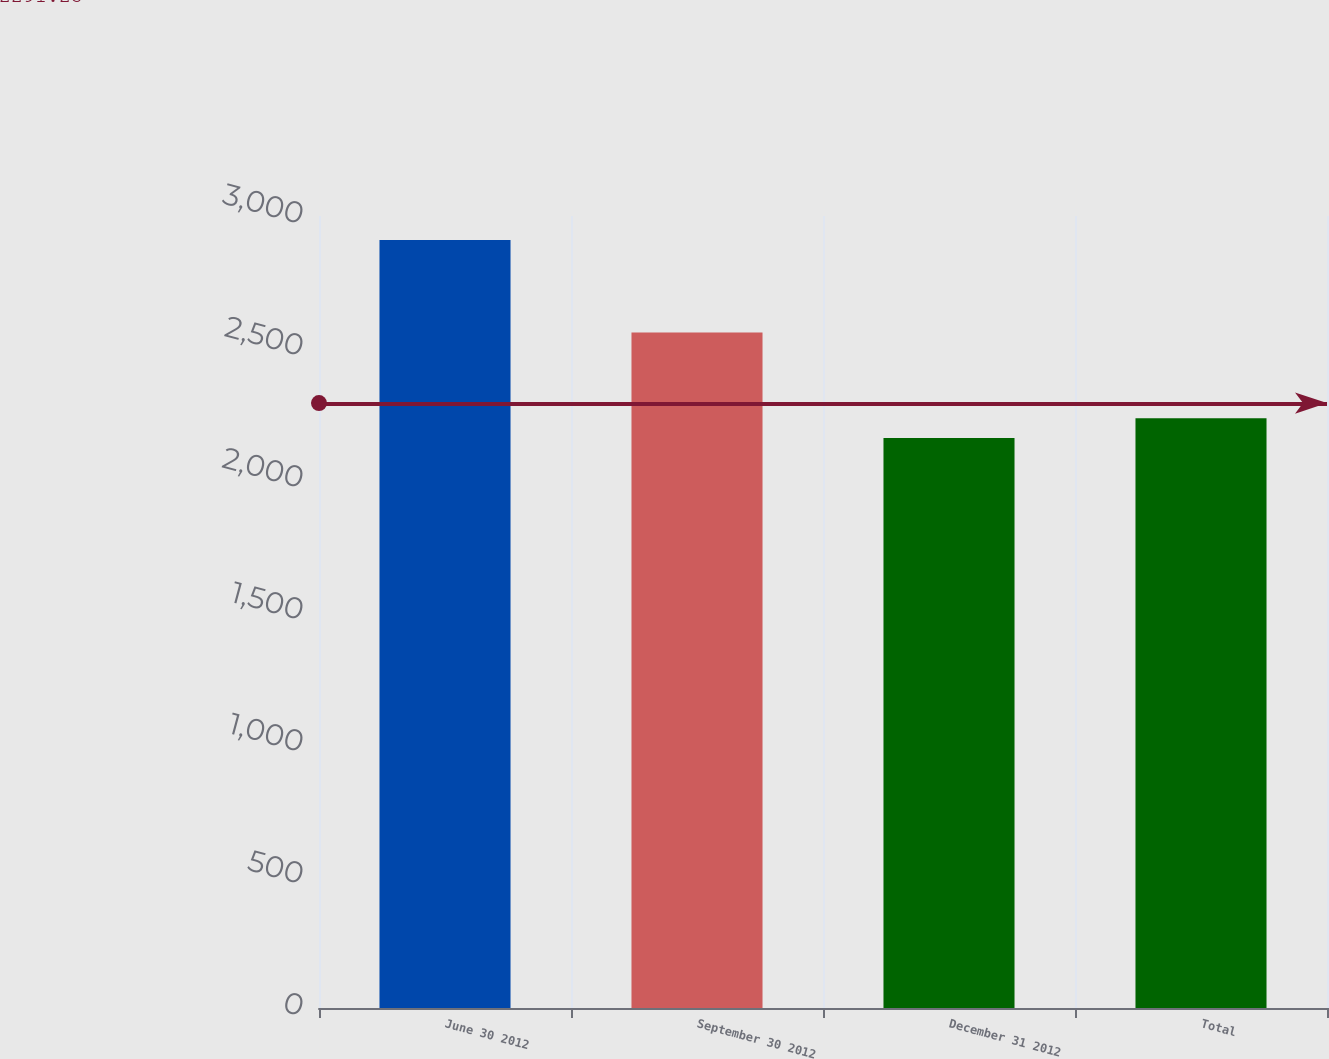<chart> <loc_0><loc_0><loc_500><loc_500><bar_chart><fcel>June 30 2012<fcel>September 30 2012<fcel>December 31 2012<fcel>Total<nl><fcel>2909<fcel>2559<fcel>2159<fcel>2234<nl></chart> 